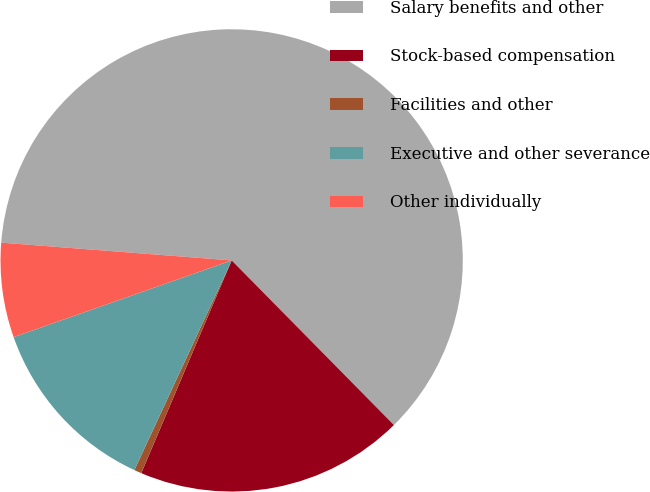Convert chart. <chart><loc_0><loc_0><loc_500><loc_500><pie_chart><fcel>Salary benefits and other<fcel>Stock-based compensation<fcel>Facilities and other<fcel>Executive and other severance<fcel>Other individually<nl><fcel>61.39%<fcel>18.78%<fcel>0.52%<fcel>12.7%<fcel>6.61%<nl></chart> 